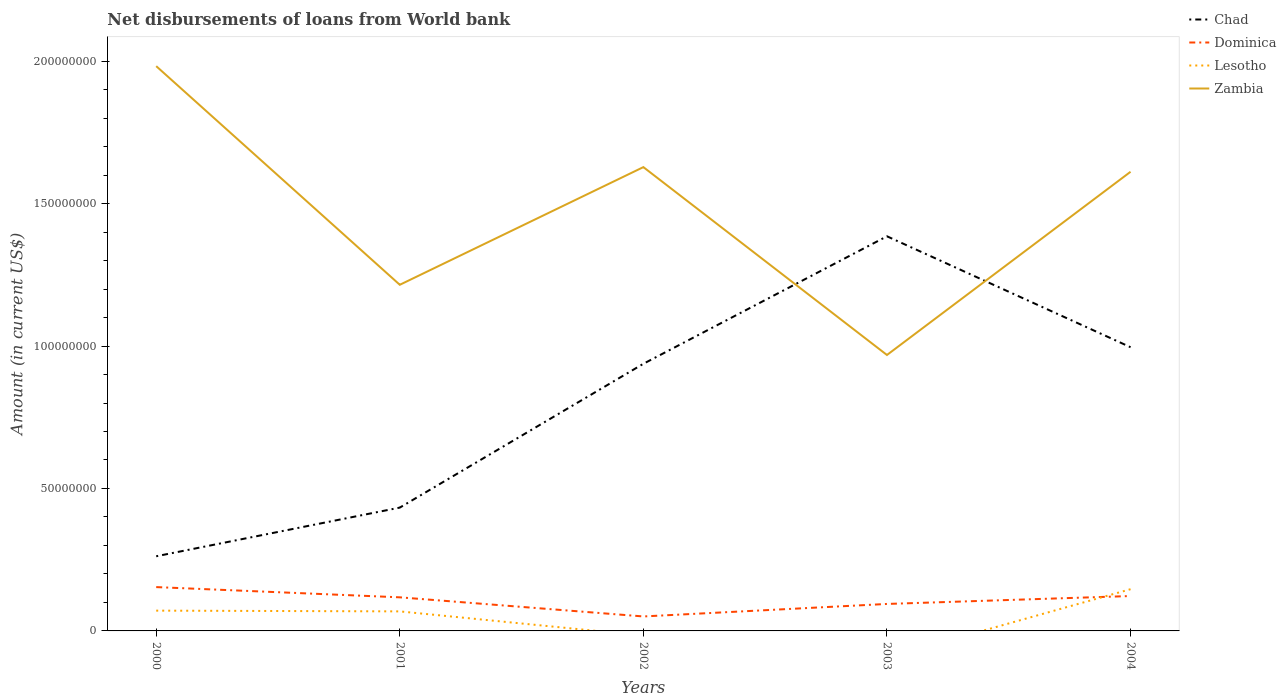How many different coloured lines are there?
Your response must be concise. 4. Does the line corresponding to Dominica intersect with the line corresponding to Lesotho?
Offer a terse response. Yes. Is the number of lines equal to the number of legend labels?
Your answer should be very brief. No. Across all years, what is the maximum amount of loan disbursed from World Bank in Chad?
Keep it short and to the point. 2.62e+07. What is the total amount of loan disbursed from World Bank in Dominica in the graph?
Provide a short and direct response. -4.39e+06. What is the difference between the highest and the second highest amount of loan disbursed from World Bank in Lesotho?
Offer a very short reply. 1.46e+07. What is the difference between the highest and the lowest amount of loan disbursed from World Bank in Dominica?
Ensure brevity in your answer.  3. How many lines are there?
Offer a terse response. 4. How many years are there in the graph?
Your response must be concise. 5. What is the difference between two consecutive major ticks on the Y-axis?
Provide a succinct answer. 5.00e+07. Are the values on the major ticks of Y-axis written in scientific E-notation?
Ensure brevity in your answer.  No. Does the graph contain grids?
Provide a succinct answer. No. Where does the legend appear in the graph?
Make the answer very short. Top right. How are the legend labels stacked?
Offer a very short reply. Vertical. What is the title of the graph?
Give a very brief answer. Net disbursements of loans from World bank. Does "Belarus" appear as one of the legend labels in the graph?
Your answer should be compact. No. What is the Amount (in current US$) of Chad in 2000?
Provide a short and direct response. 2.62e+07. What is the Amount (in current US$) of Dominica in 2000?
Your answer should be very brief. 1.54e+07. What is the Amount (in current US$) in Lesotho in 2000?
Your answer should be very brief. 7.12e+06. What is the Amount (in current US$) of Zambia in 2000?
Make the answer very short. 1.98e+08. What is the Amount (in current US$) of Chad in 2001?
Give a very brief answer. 4.33e+07. What is the Amount (in current US$) of Dominica in 2001?
Offer a terse response. 1.18e+07. What is the Amount (in current US$) of Lesotho in 2001?
Offer a terse response. 6.86e+06. What is the Amount (in current US$) in Zambia in 2001?
Your response must be concise. 1.21e+08. What is the Amount (in current US$) of Chad in 2002?
Offer a very short reply. 9.38e+07. What is the Amount (in current US$) of Dominica in 2002?
Provide a short and direct response. 5.08e+06. What is the Amount (in current US$) of Lesotho in 2002?
Make the answer very short. 0. What is the Amount (in current US$) in Zambia in 2002?
Keep it short and to the point. 1.63e+08. What is the Amount (in current US$) of Chad in 2003?
Keep it short and to the point. 1.39e+08. What is the Amount (in current US$) in Dominica in 2003?
Offer a terse response. 9.47e+06. What is the Amount (in current US$) in Zambia in 2003?
Offer a very short reply. 9.69e+07. What is the Amount (in current US$) in Chad in 2004?
Offer a terse response. 9.96e+07. What is the Amount (in current US$) of Dominica in 2004?
Your answer should be compact. 1.22e+07. What is the Amount (in current US$) of Lesotho in 2004?
Ensure brevity in your answer.  1.46e+07. What is the Amount (in current US$) of Zambia in 2004?
Provide a succinct answer. 1.61e+08. Across all years, what is the maximum Amount (in current US$) in Chad?
Offer a terse response. 1.39e+08. Across all years, what is the maximum Amount (in current US$) of Dominica?
Your answer should be compact. 1.54e+07. Across all years, what is the maximum Amount (in current US$) of Lesotho?
Your answer should be very brief. 1.46e+07. Across all years, what is the maximum Amount (in current US$) in Zambia?
Make the answer very short. 1.98e+08. Across all years, what is the minimum Amount (in current US$) of Chad?
Your answer should be very brief. 2.62e+07. Across all years, what is the minimum Amount (in current US$) of Dominica?
Make the answer very short. 5.08e+06. Across all years, what is the minimum Amount (in current US$) in Lesotho?
Keep it short and to the point. 0. Across all years, what is the minimum Amount (in current US$) in Zambia?
Provide a succinct answer. 9.69e+07. What is the total Amount (in current US$) in Chad in the graph?
Offer a terse response. 4.01e+08. What is the total Amount (in current US$) of Dominica in the graph?
Your answer should be compact. 5.40e+07. What is the total Amount (in current US$) of Lesotho in the graph?
Your response must be concise. 2.86e+07. What is the total Amount (in current US$) of Zambia in the graph?
Your answer should be compact. 7.41e+08. What is the difference between the Amount (in current US$) of Chad in 2000 and that in 2001?
Provide a short and direct response. -1.71e+07. What is the difference between the Amount (in current US$) in Dominica in 2000 and that in 2001?
Keep it short and to the point. 3.59e+06. What is the difference between the Amount (in current US$) of Lesotho in 2000 and that in 2001?
Give a very brief answer. 2.61e+05. What is the difference between the Amount (in current US$) of Zambia in 2000 and that in 2001?
Make the answer very short. 7.67e+07. What is the difference between the Amount (in current US$) in Chad in 2000 and that in 2002?
Provide a short and direct response. -6.76e+07. What is the difference between the Amount (in current US$) of Dominica in 2000 and that in 2002?
Give a very brief answer. 1.03e+07. What is the difference between the Amount (in current US$) in Zambia in 2000 and that in 2002?
Offer a very short reply. 3.54e+07. What is the difference between the Amount (in current US$) of Chad in 2000 and that in 2003?
Your answer should be compact. -1.12e+08. What is the difference between the Amount (in current US$) of Dominica in 2000 and that in 2003?
Make the answer very short. 5.92e+06. What is the difference between the Amount (in current US$) of Zambia in 2000 and that in 2003?
Your answer should be very brief. 1.01e+08. What is the difference between the Amount (in current US$) in Chad in 2000 and that in 2004?
Provide a succinct answer. -7.34e+07. What is the difference between the Amount (in current US$) of Dominica in 2000 and that in 2004?
Your answer should be compact. 3.14e+06. What is the difference between the Amount (in current US$) of Lesotho in 2000 and that in 2004?
Your response must be concise. -7.52e+06. What is the difference between the Amount (in current US$) of Zambia in 2000 and that in 2004?
Your response must be concise. 3.71e+07. What is the difference between the Amount (in current US$) in Chad in 2001 and that in 2002?
Provide a succinct answer. -5.05e+07. What is the difference between the Amount (in current US$) of Dominica in 2001 and that in 2002?
Your answer should be very brief. 6.71e+06. What is the difference between the Amount (in current US$) of Zambia in 2001 and that in 2002?
Keep it short and to the point. -4.13e+07. What is the difference between the Amount (in current US$) in Chad in 2001 and that in 2003?
Make the answer very short. -9.52e+07. What is the difference between the Amount (in current US$) in Dominica in 2001 and that in 2003?
Make the answer very short. 2.32e+06. What is the difference between the Amount (in current US$) of Zambia in 2001 and that in 2003?
Ensure brevity in your answer.  2.46e+07. What is the difference between the Amount (in current US$) of Chad in 2001 and that in 2004?
Make the answer very short. -5.63e+07. What is the difference between the Amount (in current US$) in Dominica in 2001 and that in 2004?
Offer a very short reply. -4.54e+05. What is the difference between the Amount (in current US$) of Lesotho in 2001 and that in 2004?
Provide a succinct answer. -7.78e+06. What is the difference between the Amount (in current US$) in Zambia in 2001 and that in 2004?
Keep it short and to the point. -3.97e+07. What is the difference between the Amount (in current US$) of Chad in 2002 and that in 2003?
Your answer should be very brief. -4.48e+07. What is the difference between the Amount (in current US$) of Dominica in 2002 and that in 2003?
Your answer should be very brief. -4.39e+06. What is the difference between the Amount (in current US$) in Zambia in 2002 and that in 2003?
Your answer should be very brief. 6.59e+07. What is the difference between the Amount (in current US$) of Chad in 2002 and that in 2004?
Provide a short and direct response. -5.81e+06. What is the difference between the Amount (in current US$) of Dominica in 2002 and that in 2004?
Your response must be concise. -7.17e+06. What is the difference between the Amount (in current US$) in Zambia in 2002 and that in 2004?
Your answer should be very brief. 1.63e+06. What is the difference between the Amount (in current US$) in Chad in 2003 and that in 2004?
Your response must be concise. 3.89e+07. What is the difference between the Amount (in current US$) in Dominica in 2003 and that in 2004?
Your answer should be compact. -2.78e+06. What is the difference between the Amount (in current US$) of Zambia in 2003 and that in 2004?
Provide a succinct answer. -6.43e+07. What is the difference between the Amount (in current US$) of Chad in 2000 and the Amount (in current US$) of Dominica in 2001?
Provide a succinct answer. 1.44e+07. What is the difference between the Amount (in current US$) of Chad in 2000 and the Amount (in current US$) of Lesotho in 2001?
Your response must be concise. 1.93e+07. What is the difference between the Amount (in current US$) of Chad in 2000 and the Amount (in current US$) of Zambia in 2001?
Give a very brief answer. -9.53e+07. What is the difference between the Amount (in current US$) of Dominica in 2000 and the Amount (in current US$) of Lesotho in 2001?
Your answer should be very brief. 8.53e+06. What is the difference between the Amount (in current US$) in Dominica in 2000 and the Amount (in current US$) in Zambia in 2001?
Your response must be concise. -1.06e+08. What is the difference between the Amount (in current US$) of Lesotho in 2000 and the Amount (in current US$) of Zambia in 2001?
Provide a succinct answer. -1.14e+08. What is the difference between the Amount (in current US$) in Chad in 2000 and the Amount (in current US$) in Dominica in 2002?
Provide a succinct answer. 2.11e+07. What is the difference between the Amount (in current US$) of Chad in 2000 and the Amount (in current US$) of Zambia in 2002?
Keep it short and to the point. -1.37e+08. What is the difference between the Amount (in current US$) in Dominica in 2000 and the Amount (in current US$) in Zambia in 2002?
Your response must be concise. -1.47e+08. What is the difference between the Amount (in current US$) of Lesotho in 2000 and the Amount (in current US$) of Zambia in 2002?
Offer a very short reply. -1.56e+08. What is the difference between the Amount (in current US$) of Chad in 2000 and the Amount (in current US$) of Dominica in 2003?
Your answer should be very brief. 1.67e+07. What is the difference between the Amount (in current US$) of Chad in 2000 and the Amount (in current US$) of Zambia in 2003?
Your response must be concise. -7.07e+07. What is the difference between the Amount (in current US$) in Dominica in 2000 and the Amount (in current US$) in Zambia in 2003?
Your response must be concise. -8.15e+07. What is the difference between the Amount (in current US$) in Lesotho in 2000 and the Amount (in current US$) in Zambia in 2003?
Give a very brief answer. -8.97e+07. What is the difference between the Amount (in current US$) in Chad in 2000 and the Amount (in current US$) in Dominica in 2004?
Provide a short and direct response. 1.40e+07. What is the difference between the Amount (in current US$) of Chad in 2000 and the Amount (in current US$) of Lesotho in 2004?
Your answer should be compact. 1.16e+07. What is the difference between the Amount (in current US$) of Chad in 2000 and the Amount (in current US$) of Zambia in 2004?
Provide a succinct answer. -1.35e+08. What is the difference between the Amount (in current US$) of Dominica in 2000 and the Amount (in current US$) of Lesotho in 2004?
Ensure brevity in your answer.  7.42e+05. What is the difference between the Amount (in current US$) of Dominica in 2000 and the Amount (in current US$) of Zambia in 2004?
Your response must be concise. -1.46e+08. What is the difference between the Amount (in current US$) in Lesotho in 2000 and the Amount (in current US$) in Zambia in 2004?
Give a very brief answer. -1.54e+08. What is the difference between the Amount (in current US$) in Chad in 2001 and the Amount (in current US$) in Dominica in 2002?
Provide a succinct answer. 3.82e+07. What is the difference between the Amount (in current US$) in Chad in 2001 and the Amount (in current US$) in Zambia in 2002?
Keep it short and to the point. -1.20e+08. What is the difference between the Amount (in current US$) of Dominica in 2001 and the Amount (in current US$) of Zambia in 2002?
Offer a terse response. -1.51e+08. What is the difference between the Amount (in current US$) of Lesotho in 2001 and the Amount (in current US$) of Zambia in 2002?
Provide a short and direct response. -1.56e+08. What is the difference between the Amount (in current US$) in Chad in 2001 and the Amount (in current US$) in Dominica in 2003?
Your answer should be compact. 3.38e+07. What is the difference between the Amount (in current US$) in Chad in 2001 and the Amount (in current US$) in Zambia in 2003?
Provide a short and direct response. -5.36e+07. What is the difference between the Amount (in current US$) of Dominica in 2001 and the Amount (in current US$) of Zambia in 2003?
Give a very brief answer. -8.51e+07. What is the difference between the Amount (in current US$) in Lesotho in 2001 and the Amount (in current US$) in Zambia in 2003?
Provide a short and direct response. -9.00e+07. What is the difference between the Amount (in current US$) in Chad in 2001 and the Amount (in current US$) in Dominica in 2004?
Your answer should be compact. 3.10e+07. What is the difference between the Amount (in current US$) in Chad in 2001 and the Amount (in current US$) in Lesotho in 2004?
Offer a terse response. 2.86e+07. What is the difference between the Amount (in current US$) of Chad in 2001 and the Amount (in current US$) of Zambia in 2004?
Give a very brief answer. -1.18e+08. What is the difference between the Amount (in current US$) in Dominica in 2001 and the Amount (in current US$) in Lesotho in 2004?
Ensure brevity in your answer.  -2.85e+06. What is the difference between the Amount (in current US$) in Dominica in 2001 and the Amount (in current US$) in Zambia in 2004?
Keep it short and to the point. -1.49e+08. What is the difference between the Amount (in current US$) in Lesotho in 2001 and the Amount (in current US$) in Zambia in 2004?
Provide a succinct answer. -1.54e+08. What is the difference between the Amount (in current US$) of Chad in 2002 and the Amount (in current US$) of Dominica in 2003?
Your response must be concise. 8.43e+07. What is the difference between the Amount (in current US$) in Chad in 2002 and the Amount (in current US$) in Zambia in 2003?
Your response must be concise. -3.08e+06. What is the difference between the Amount (in current US$) in Dominica in 2002 and the Amount (in current US$) in Zambia in 2003?
Offer a very short reply. -9.18e+07. What is the difference between the Amount (in current US$) in Chad in 2002 and the Amount (in current US$) in Dominica in 2004?
Keep it short and to the point. 8.15e+07. What is the difference between the Amount (in current US$) in Chad in 2002 and the Amount (in current US$) in Lesotho in 2004?
Ensure brevity in your answer.  7.91e+07. What is the difference between the Amount (in current US$) in Chad in 2002 and the Amount (in current US$) in Zambia in 2004?
Give a very brief answer. -6.74e+07. What is the difference between the Amount (in current US$) in Dominica in 2002 and the Amount (in current US$) in Lesotho in 2004?
Keep it short and to the point. -9.56e+06. What is the difference between the Amount (in current US$) in Dominica in 2002 and the Amount (in current US$) in Zambia in 2004?
Your answer should be compact. -1.56e+08. What is the difference between the Amount (in current US$) of Chad in 2003 and the Amount (in current US$) of Dominica in 2004?
Keep it short and to the point. 1.26e+08. What is the difference between the Amount (in current US$) of Chad in 2003 and the Amount (in current US$) of Lesotho in 2004?
Offer a very short reply. 1.24e+08. What is the difference between the Amount (in current US$) in Chad in 2003 and the Amount (in current US$) in Zambia in 2004?
Your answer should be compact. -2.26e+07. What is the difference between the Amount (in current US$) of Dominica in 2003 and the Amount (in current US$) of Lesotho in 2004?
Provide a short and direct response. -5.18e+06. What is the difference between the Amount (in current US$) in Dominica in 2003 and the Amount (in current US$) in Zambia in 2004?
Your answer should be very brief. -1.52e+08. What is the average Amount (in current US$) in Chad per year?
Provide a short and direct response. 8.03e+07. What is the average Amount (in current US$) of Dominica per year?
Your answer should be very brief. 1.08e+07. What is the average Amount (in current US$) in Lesotho per year?
Give a very brief answer. 5.72e+06. What is the average Amount (in current US$) of Zambia per year?
Give a very brief answer. 1.48e+08. In the year 2000, what is the difference between the Amount (in current US$) of Chad and Amount (in current US$) of Dominica?
Offer a very short reply. 1.08e+07. In the year 2000, what is the difference between the Amount (in current US$) of Chad and Amount (in current US$) of Lesotho?
Offer a very short reply. 1.91e+07. In the year 2000, what is the difference between the Amount (in current US$) in Chad and Amount (in current US$) in Zambia?
Offer a very short reply. -1.72e+08. In the year 2000, what is the difference between the Amount (in current US$) of Dominica and Amount (in current US$) of Lesotho?
Keep it short and to the point. 8.27e+06. In the year 2000, what is the difference between the Amount (in current US$) in Dominica and Amount (in current US$) in Zambia?
Ensure brevity in your answer.  -1.83e+08. In the year 2000, what is the difference between the Amount (in current US$) of Lesotho and Amount (in current US$) of Zambia?
Ensure brevity in your answer.  -1.91e+08. In the year 2001, what is the difference between the Amount (in current US$) of Chad and Amount (in current US$) of Dominica?
Provide a short and direct response. 3.15e+07. In the year 2001, what is the difference between the Amount (in current US$) of Chad and Amount (in current US$) of Lesotho?
Your response must be concise. 3.64e+07. In the year 2001, what is the difference between the Amount (in current US$) of Chad and Amount (in current US$) of Zambia?
Keep it short and to the point. -7.82e+07. In the year 2001, what is the difference between the Amount (in current US$) in Dominica and Amount (in current US$) in Lesotho?
Make the answer very short. 4.93e+06. In the year 2001, what is the difference between the Amount (in current US$) in Dominica and Amount (in current US$) in Zambia?
Provide a succinct answer. -1.10e+08. In the year 2001, what is the difference between the Amount (in current US$) of Lesotho and Amount (in current US$) of Zambia?
Keep it short and to the point. -1.15e+08. In the year 2002, what is the difference between the Amount (in current US$) of Chad and Amount (in current US$) of Dominica?
Provide a succinct answer. 8.87e+07. In the year 2002, what is the difference between the Amount (in current US$) of Chad and Amount (in current US$) of Zambia?
Your response must be concise. -6.90e+07. In the year 2002, what is the difference between the Amount (in current US$) of Dominica and Amount (in current US$) of Zambia?
Make the answer very short. -1.58e+08. In the year 2003, what is the difference between the Amount (in current US$) in Chad and Amount (in current US$) in Dominica?
Your response must be concise. 1.29e+08. In the year 2003, what is the difference between the Amount (in current US$) in Chad and Amount (in current US$) in Zambia?
Your answer should be very brief. 4.17e+07. In the year 2003, what is the difference between the Amount (in current US$) in Dominica and Amount (in current US$) in Zambia?
Offer a terse response. -8.74e+07. In the year 2004, what is the difference between the Amount (in current US$) of Chad and Amount (in current US$) of Dominica?
Make the answer very short. 8.73e+07. In the year 2004, what is the difference between the Amount (in current US$) in Chad and Amount (in current US$) in Lesotho?
Your answer should be very brief. 8.49e+07. In the year 2004, what is the difference between the Amount (in current US$) of Chad and Amount (in current US$) of Zambia?
Ensure brevity in your answer.  -6.16e+07. In the year 2004, what is the difference between the Amount (in current US$) of Dominica and Amount (in current US$) of Lesotho?
Provide a succinct answer. -2.40e+06. In the year 2004, what is the difference between the Amount (in current US$) in Dominica and Amount (in current US$) in Zambia?
Your answer should be compact. -1.49e+08. In the year 2004, what is the difference between the Amount (in current US$) of Lesotho and Amount (in current US$) of Zambia?
Keep it short and to the point. -1.47e+08. What is the ratio of the Amount (in current US$) of Chad in 2000 to that in 2001?
Your answer should be compact. 0.61. What is the ratio of the Amount (in current US$) in Dominica in 2000 to that in 2001?
Provide a succinct answer. 1.3. What is the ratio of the Amount (in current US$) in Lesotho in 2000 to that in 2001?
Offer a terse response. 1.04. What is the ratio of the Amount (in current US$) in Zambia in 2000 to that in 2001?
Your answer should be compact. 1.63. What is the ratio of the Amount (in current US$) in Chad in 2000 to that in 2002?
Provide a short and direct response. 0.28. What is the ratio of the Amount (in current US$) of Dominica in 2000 to that in 2002?
Your response must be concise. 3.03. What is the ratio of the Amount (in current US$) of Zambia in 2000 to that in 2002?
Make the answer very short. 1.22. What is the ratio of the Amount (in current US$) of Chad in 2000 to that in 2003?
Make the answer very short. 0.19. What is the ratio of the Amount (in current US$) of Dominica in 2000 to that in 2003?
Provide a short and direct response. 1.62. What is the ratio of the Amount (in current US$) in Zambia in 2000 to that in 2003?
Keep it short and to the point. 2.05. What is the ratio of the Amount (in current US$) of Chad in 2000 to that in 2004?
Give a very brief answer. 0.26. What is the ratio of the Amount (in current US$) of Dominica in 2000 to that in 2004?
Your answer should be compact. 1.26. What is the ratio of the Amount (in current US$) of Lesotho in 2000 to that in 2004?
Give a very brief answer. 0.49. What is the ratio of the Amount (in current US$) in Zambia in 2000 to that in 2004?
Your answer should be compact. 1.23. What is the ratio of the Amount (in current US$) in Chad in 2001 to that in 2002?
Your answer should be very brief. 0.46. What is the ratio of the Amount (in current US$) of Dominica in 2001 to that in 2002?
Offer a very short reply. 2.32. What is the ratio of the Amount (in current US$) of Zambia in 2001 to that in 2002?
Make the answer very short. 0.75. What is the ratio of the Amount (in current US$) of Chad in 2001 to that in 2003?
Provide a short and direct response. 0.31. What is the ratio of the Amount (in current US$) in Dominica in 2001 to that in 2003?
Provide a short and direct response. 1.25. What is the ratio of the Amount (in current US$) in Zambia in 2001 to that in 2003?
Ensure brevity in your answer.  1.25. What is the ratio of the Amount (in current US$) in Chad in 2001 to that in 2004?
Make the answer very short. 0.43. What is the ratio of the Amount (in current US$) of Dominica in 2001 to that in 2004?
Your response must be concise. 0.96. What is the ratio of the Amount (in current US$) of Lesotho in 2001 to that in 2004?
Provide a short and direct response. 0.47. What is the ratio of the Amount (in current US$) of Zambia in 2001 to that in 2004?
Provide a succinct answer. 0.75. What is the ratio of the Amount (in current US$) in Chad in 2002 to that in 2003?
Your answer should be compact. 0.68. What is the ratio of the Amount (in current US$) of Dominica in 2002 to that in 2003?
Provide a short and direct response. 0.54. What is the ratio of the Amount (in current US$) in Zambia in 2002 to that in 2003?
Provide a succinct answer. 1.68. What is the ratio of the Amount (in current US$) in Chad in 2002 to that in 2004?
Keep it short and to the point. 0.94. What is the ratio of the Amount (in current US$) of Dominica in 2002 to that in 2004?
Your response must be concise. 0.41. What is the ratio of the Amount (in current US$) of Chad in 2003 to that in 2004?
Keep it short and to the point. 1.39. What is the ratio of the Amount (in current US$) of Dominica in 2003 to that in 2004?
Provide a succinct answer. 0.77. What is the ratio of the Amount (in current US$) of Zambia in 2003 to that in 2004?
Give a very brief answer. 0.6. What is the difference between the highest and the second highest Amount (in current US$) in Chad?
Offer a terse response. 3.89e+07. What is the difference between the highest and the second highest Amount (in current US$) in Dominica?
Your answer should be compact. 3.14e+06. What is the difference between the highest and the second highest Amount (in current US$) in Lesotho?
Keep it short and to the point. 7.52e+06. What is the difference between the highest and the second highest Amount (in current US$) in Zambia?
Provide a short and direct response. 3.54e+07. What is the difference between the highest and the lowest Amount (in current US$) of Chad?
Your answer should be very brief. 1.12e+08. What is the difference between the highest and the lowest Amount (in current US$) in Dominica?
Give a very brief answer. 1.03e+07. What is the difference between the highest and the lowest Amount (in current US$) of Lesotho?
Your response must be concise. 1.46e+07. What is the difference between the highest and the lowest Amount (in current US$) of Zambia?
Your answer should be very brief. 1.01e+08. 